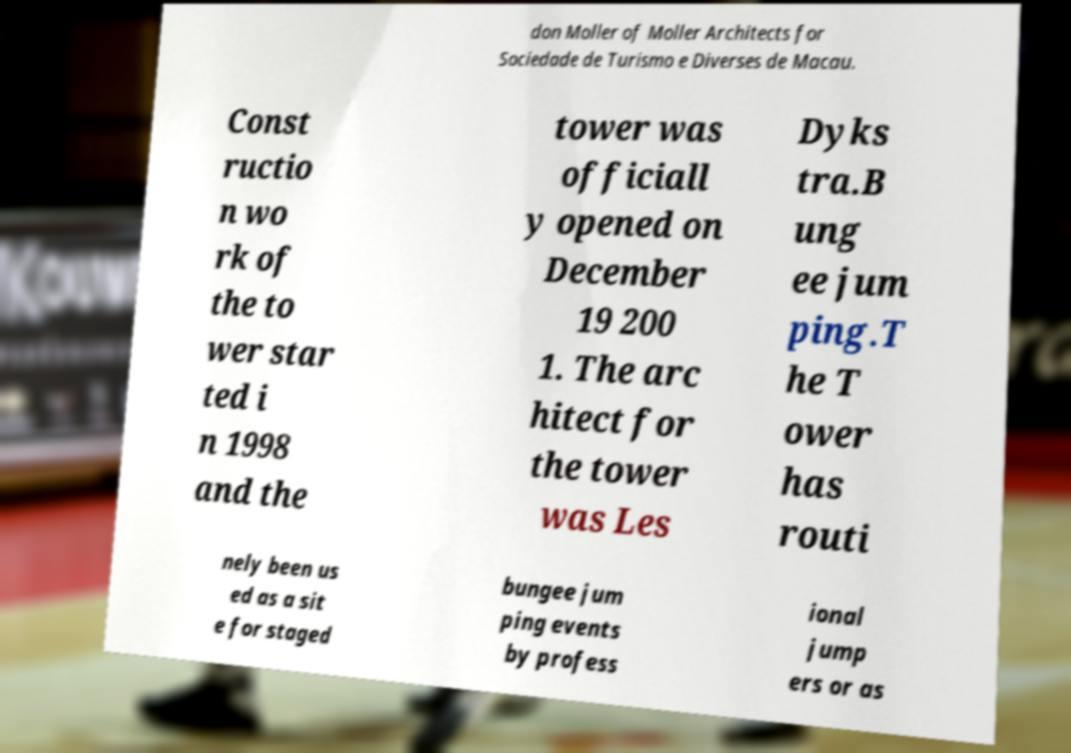Could you assist in decoding the text presented in this image and type it out clearly? don Moller of Moller Architects for Sociedade de Turismo e Diverses de Macau. Const ructio n wo rk of the to wer star ted i n 1998 and the tower was officiall y opened on December 19 200 1. The arc hitect for the tower was Les Dyks tra.B ung ee jum ping.T he T ower has routi nely been us ed as a sit e for staged bungee jum ping events by profess ional jump ers or as 